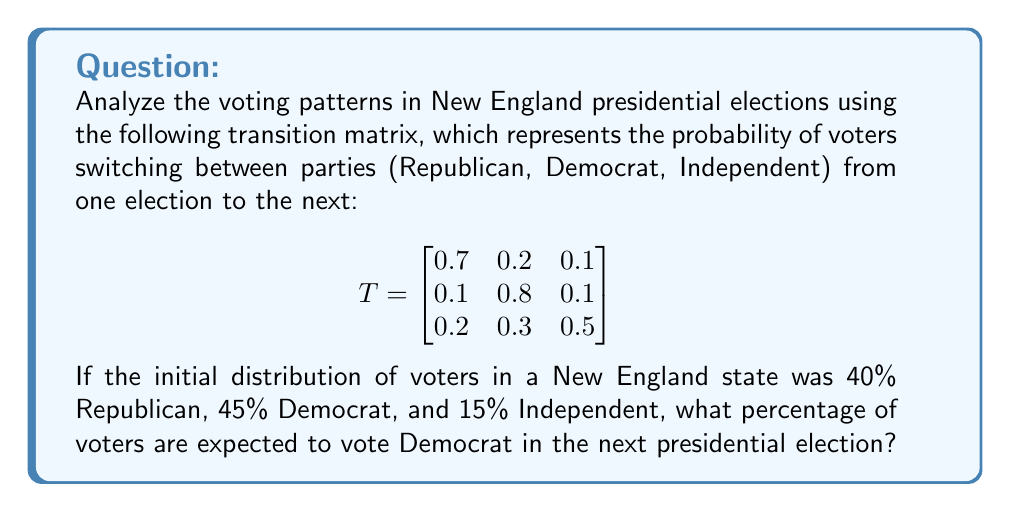Help me with this question. Let's approach this step-by-step:

1) First, we need to represent the initial distribution of voters as a row vector:

   $v_0 = \begin{bmatrix} 0.4 & 0.45 & 0.15 \end{bmatrix}$

2) To find the distribution of voters in the next election, we multiply this vector by the transition matrix:

   $v_1 = v_0 \cdot T$

3) Let's perform this multiplication:

   $v_1 = \begin{bmatrix} 0.4 & 0.45 & 0.15 \end{bmatrix} \cdot \begin{bmatrix}
   0.7 & 0.2 & 0.1 \\
   0.1 & 0.8 & 0.1 \\
   0.2 & 0.3 & 0.5
   \end{bmatrix}$

4) Calculating each element:
   
   $(0.4 \cdot 0.7 + 0.45 \cdot 0.1 + 0.15 \cdot 0.2) = 0.355$
   $(0.4 \cdot 0.2 + 0.45 \cdot 0.8 + 0.15 \cdot 0.3) = 0.485$
   $(0.4 \cdot 0.1 + 0.45 \cdot 0.1 + 0.15 \cdot 0.5) = 0.16$

5) Therefore, $v_1 = \begin{bmatrix} 0.355 & 0.485 & 0.16 \end{bmatrix}$

6) The percentage of voters expected to vote Democrat in the next election is the second element of this vector, which is 0.485 or 48.5%.
Answer: 48.5% 